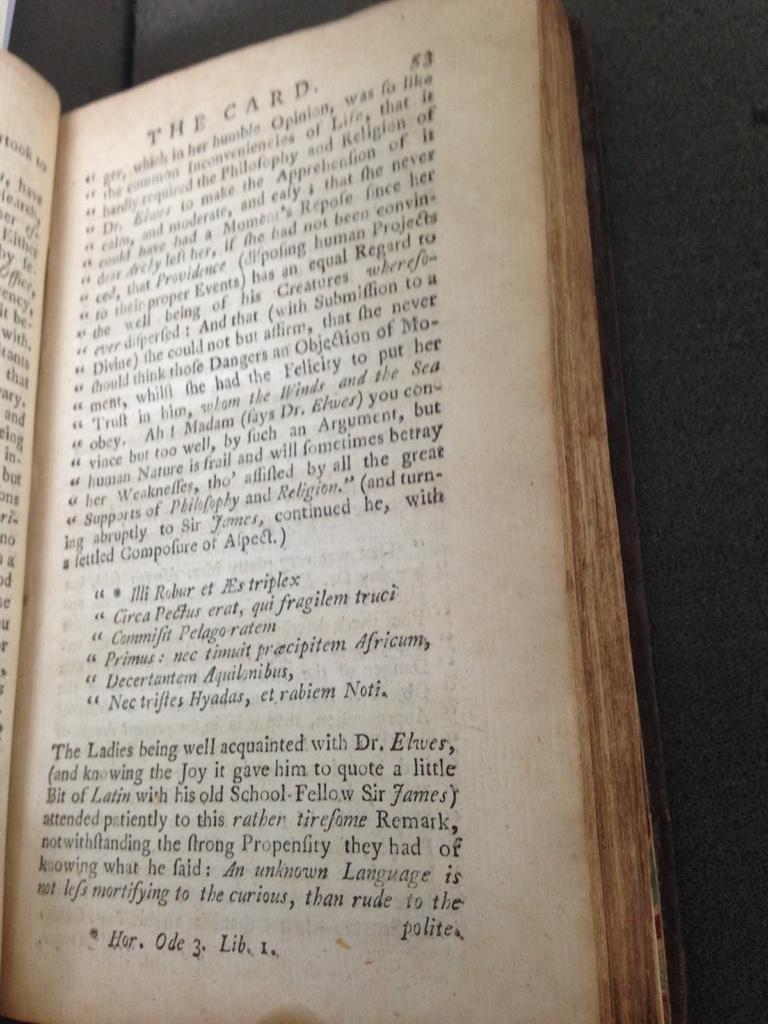<image>
Give a short and clear explanation of the subsequent image. the book, the Card, is open near the center of the book 